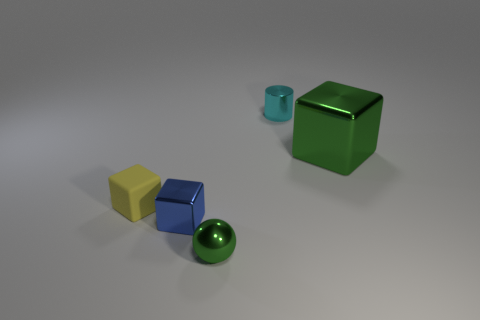There is a matte object that is the same size as the blue metal object; what color is it? yellow 